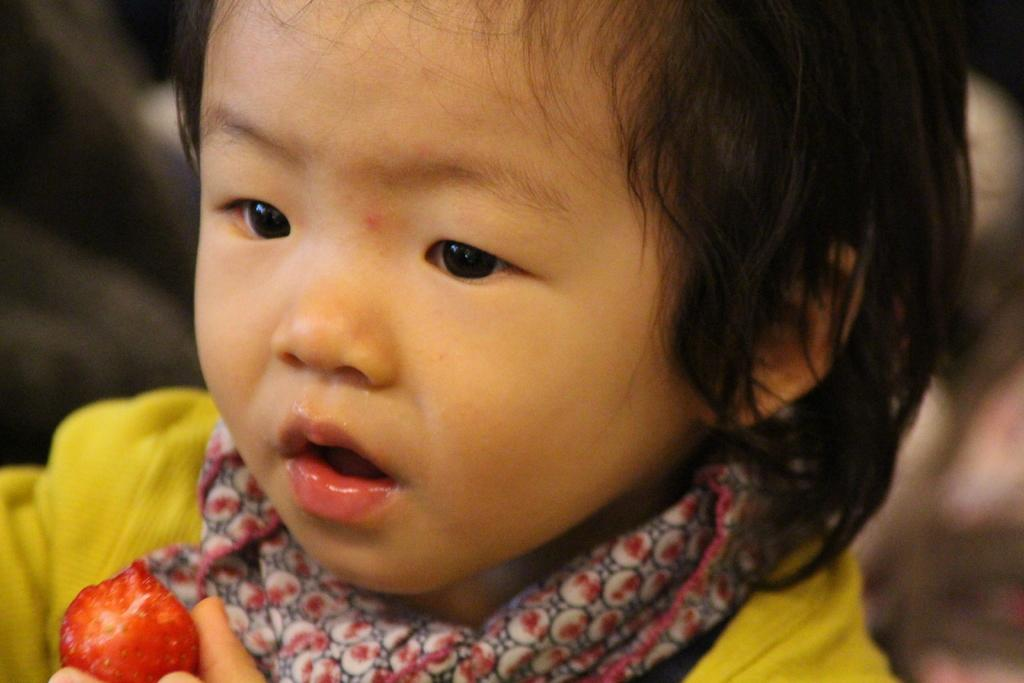What is the main subject of the picture? The main subject of the picture is a kid. Can you describe what the human hand is doing in the picture? The human hand is holding a strawberry. What type of offer is being made by the kid in the picture? There is no offer being made in the image, as it only shows a kid and a human hand holding a strawberry. 